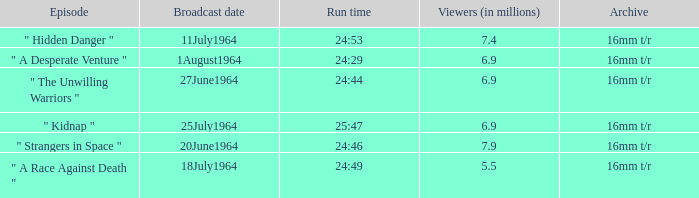How many viewers were there on 1august1964? 6.9. 